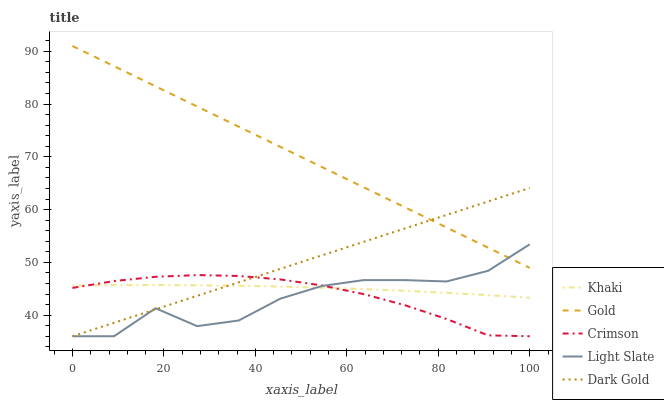Does Khaki have the minimum area under the curve?
Answer yes or no. No. Does Khaki have the maximum area under the curve?
Answer yes or no. No. Is Khaki the smoothest?
Answer yes or no. No. Is Khaki the roughest?
Answer yes or no. No. Does Khaki have the lowest value?
Answer yes or no. No. Does Light Slate have the highest value?
Answer yes or no. No. Is Crimson less than Gold?
Answer yes or no. Yes. Is Gold greater than Crimson?
Answer yes or no. Yes. Does Crimson intersect Gold?
Answer yes or no. No. 